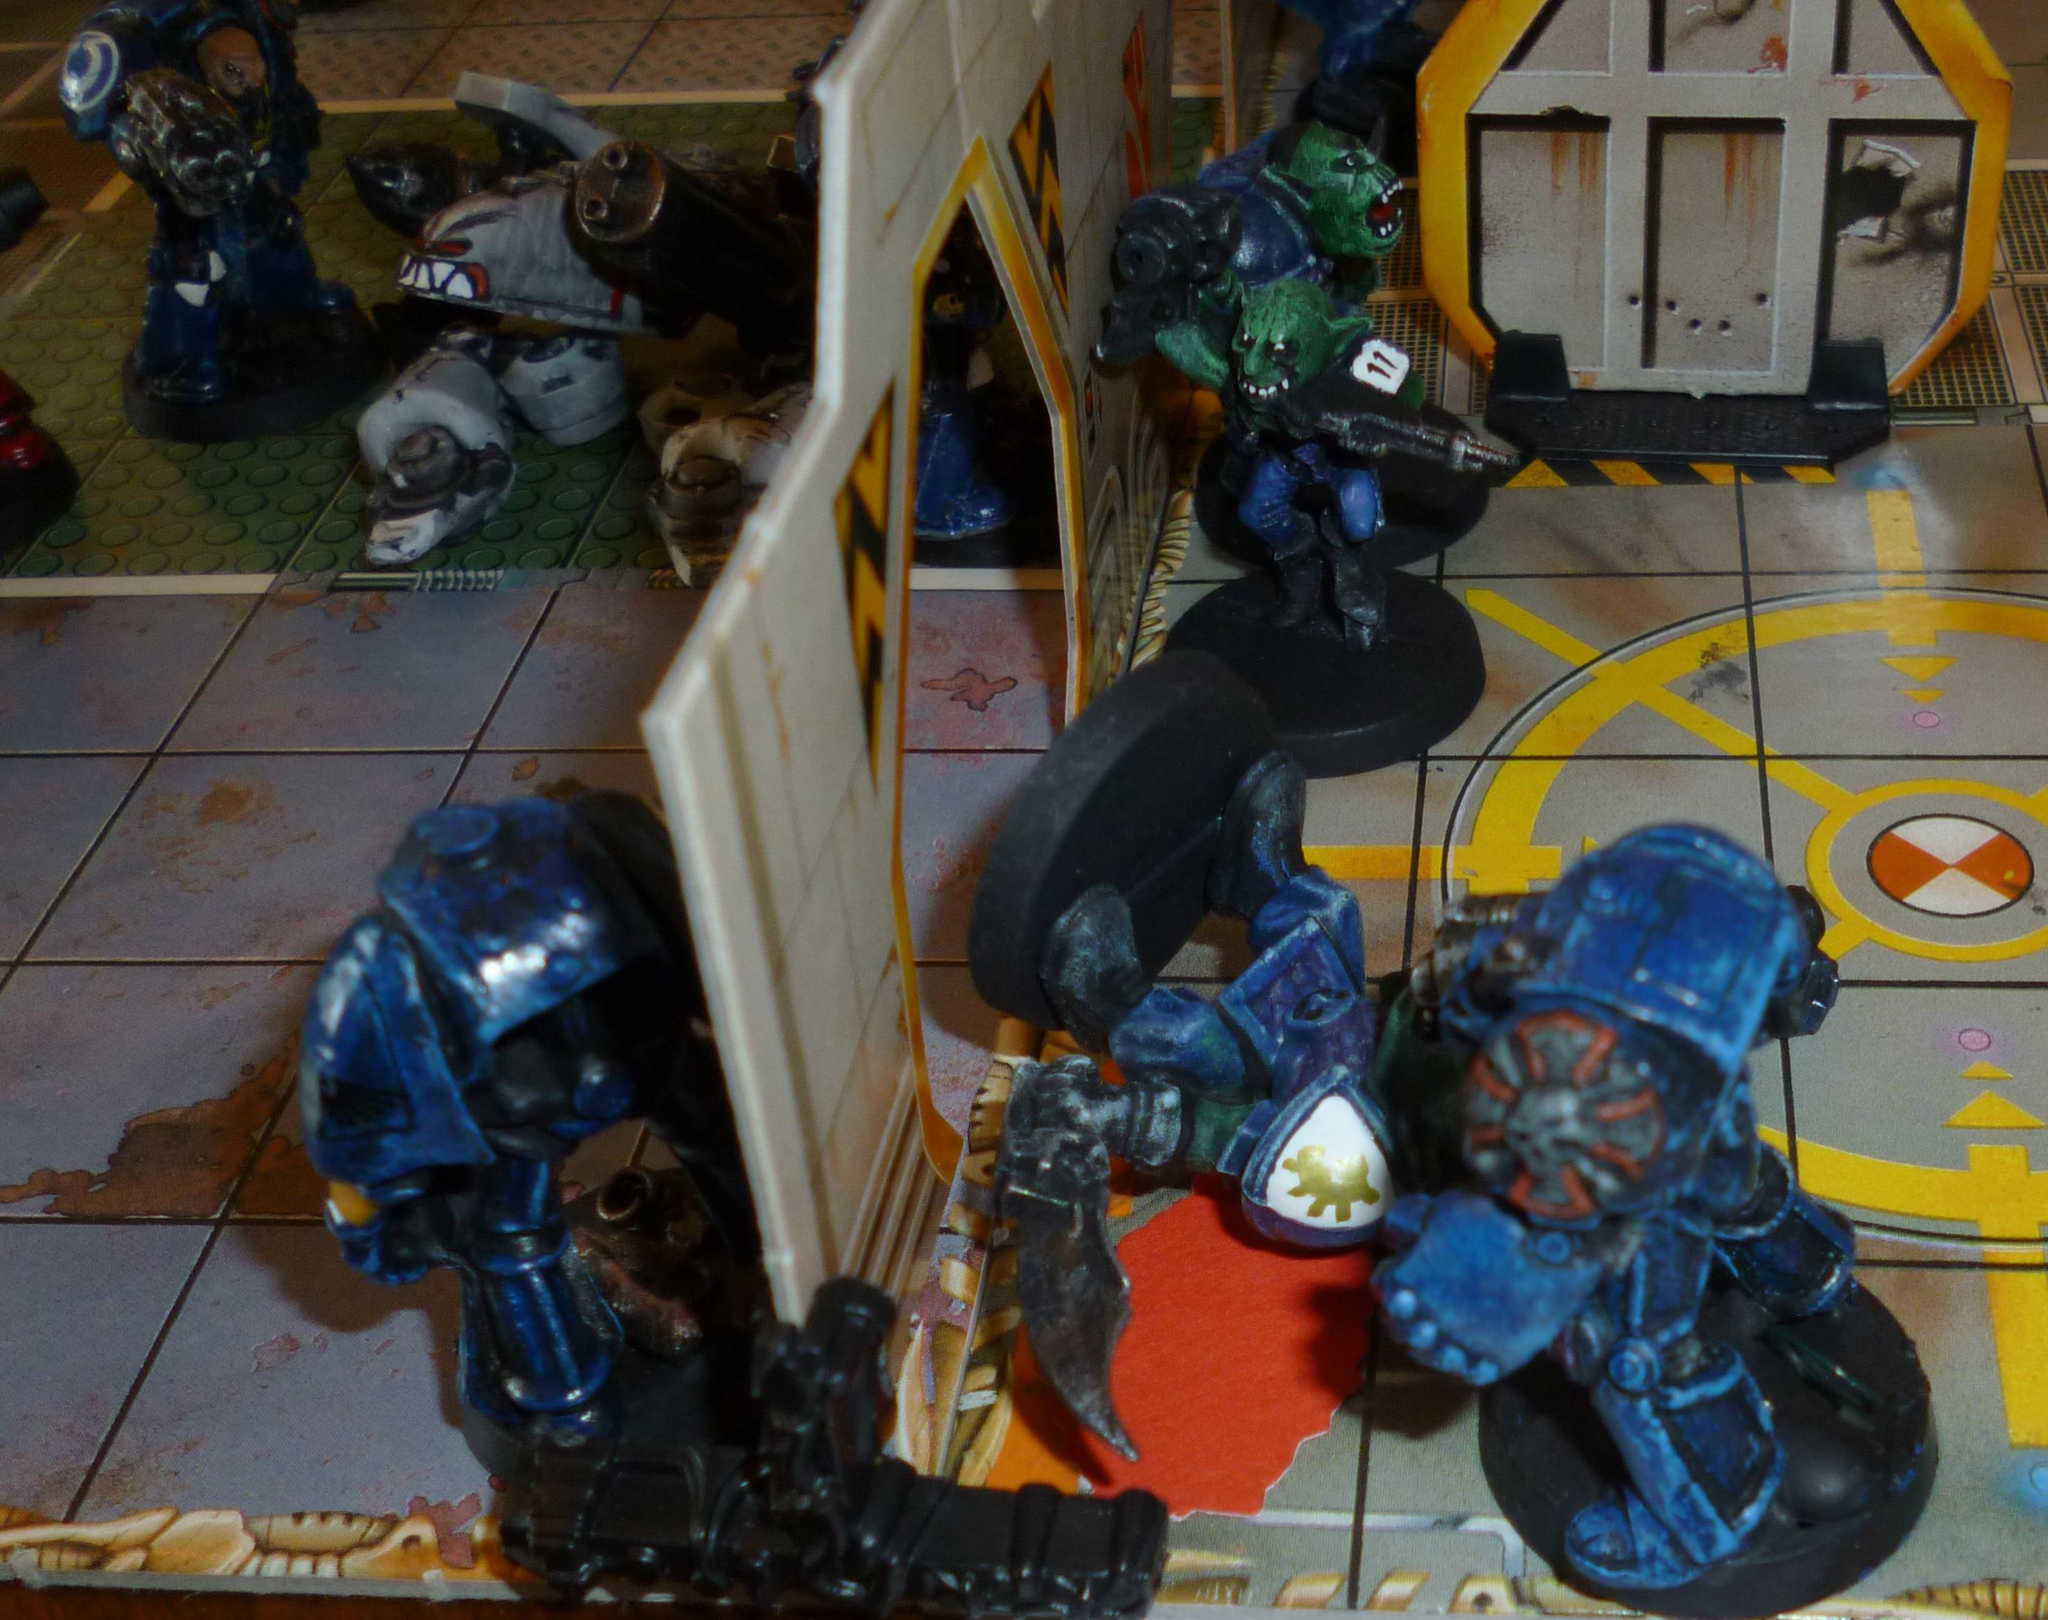What types of objects can be seen in the image? There are many objects in the image, and they have different shapes. What might these objects be used for? The objects are likely to be toys, given their shapes and variety. What type of shirt is being worn by the quiet person in the park? There is no person, quiet or otherwise, wearing a shirt in the park, as the image only contains toys. 